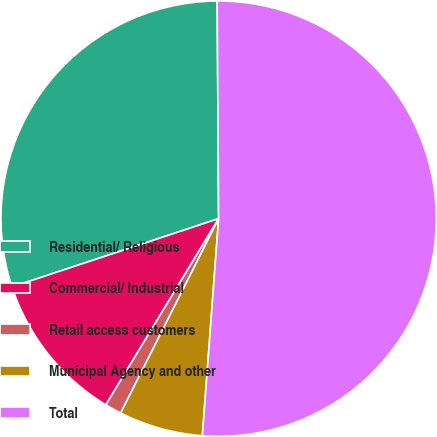<chart> <loc_0><loc_0><loc_500><loc_500><pie_chart><fcel>Residential/ Religious<fcel>Commercial/ Industrial<fcel>Retail access customers<fcel>Municipal Agency and other<fcel>Total<nl><fcel>29.98%<fcel>11.25%<fcel>1.24%<fcel>6.24%<fcel>51.3%<nl></chart> 